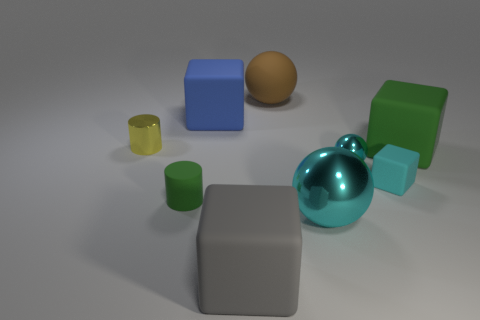Add 1 large cyan rubber things. How many objects exist? 10 Subtract all tiny rubber cubes. How many cubes are left? 3 Subtract 2 cyan spheres. How many objects are left? 7 Subtract all balls. How many objects are left? 6 Subtract 1 balls. How many balls are left? 2 Subtract all green cubes. Subtract all green balls. How many cubes are left? 3 Subtract all blue cylinders. How many cyan balls are left? 2 Subtract all small yellow metallic cylinders. Subtract all cyan cubes. How many objects are left? 7 Add 7 rubber cylinders. How many rubber cylinders are left? 8 Add 7 small cyan balls. How many small cyan balls exist? 8 